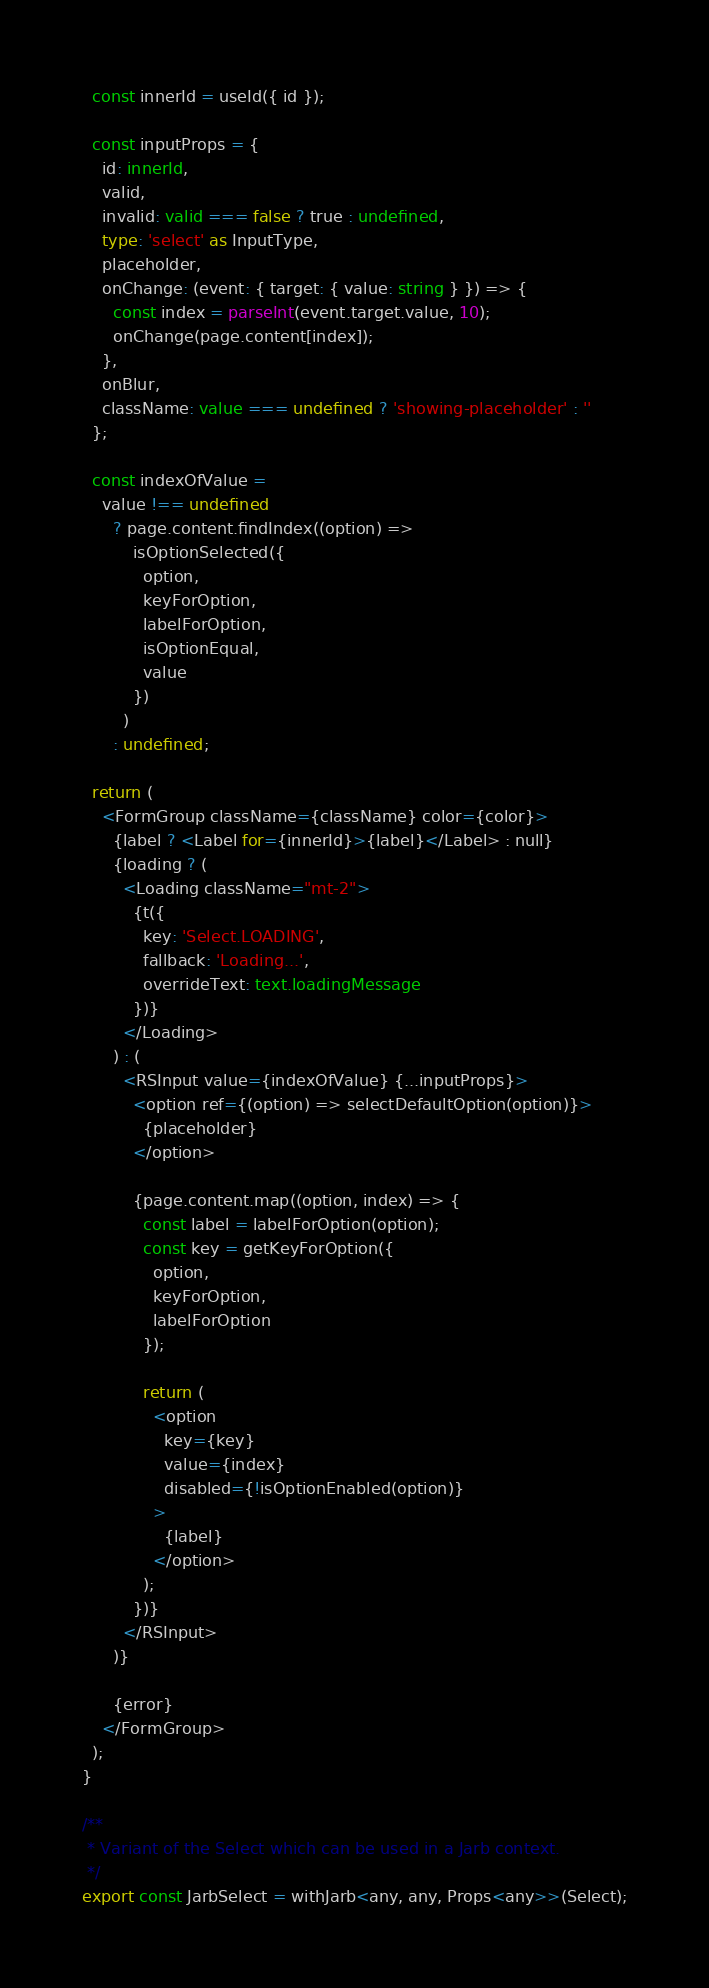<code> <loc_0><loc_0><loc_500><loc_500><_TypeScript_>  const innerId = useId({ id });

  const inputProps = {
    id: innerId,
    valid,
    invalid: valid === false ? true : undefined,
    type: 'select' as InputType,
    placeholder,
    onChange: (event: { target: { value: string } }) => {
      const index = parseInt(event.target.value, 10);
      onChange(page.content[index]);
    },
    onBlur,
    className: value === undefined ? 'showing-placeholder' : ''
  };

  const indexOfValue =
    value !== undefined
      ? page.content.findIndex((option) =>
          isOptionSelected({
            option,
            keyForOption,
            labelForOption,
            isOptionEqual,
            value
          })
        )
      : undefined;

  return (
    <FormGroup className={className} color={color}>
      {label ? <Label for={innerId}>{label}</Label> : null}
      {loading ? (
        <Loading className="mt-2">
          {t({
            key: 'Select.LOADING',
            fallback: 'Loading...',
            overrideText: text.loadingMessage
          })}
        </Loading>
      ) : (
        <RSInput value={indexOfValue} {...inputProps}>
          <option ref={(option) => selectDefaultOption(option)}>
            {placeholder}
          </option>

          {page.content.map((option, index) => {
            const label = labelForOption(option);
            const key = getKeyForOption({
              option,
              keyForOption,
              labelForOption
            });

            return (
              <option
                key={key}
                value={index}
                disabled={!isOptionEnabled(option)}
              >
                {label}
              </option>
            );
          })}
        </RSInput>
      )}

      {error}
    </FormGroup>
  );
}

/**
 * Variant of the Select which can be used in a Jarb context.
 */
export const JarbSelect = withJarb<any, any, Props<any>>(Select);
</code> 